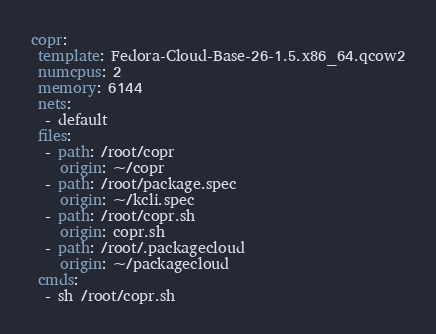Convert code to text. <code><loc_0><loc_0><loc_500><loc_500><_YAML_>copr:
 template: Fedora-Cloud-Base-26-1.5.x86_64.qcow2
 numcpus: 2
 memory: 6144
 nets:
  - default
 files:
  - path: /root/copr
    origin: ~/copr
  - path: /root/package.spec
    origin: ~/kcli.spec
  - path: /root/copr.sh
    origin: copr.sh
  - path: /root/.packagecloud
    origin: ~/packagecloud
 cmds:
  - sh /root/copr.sh
</code> 